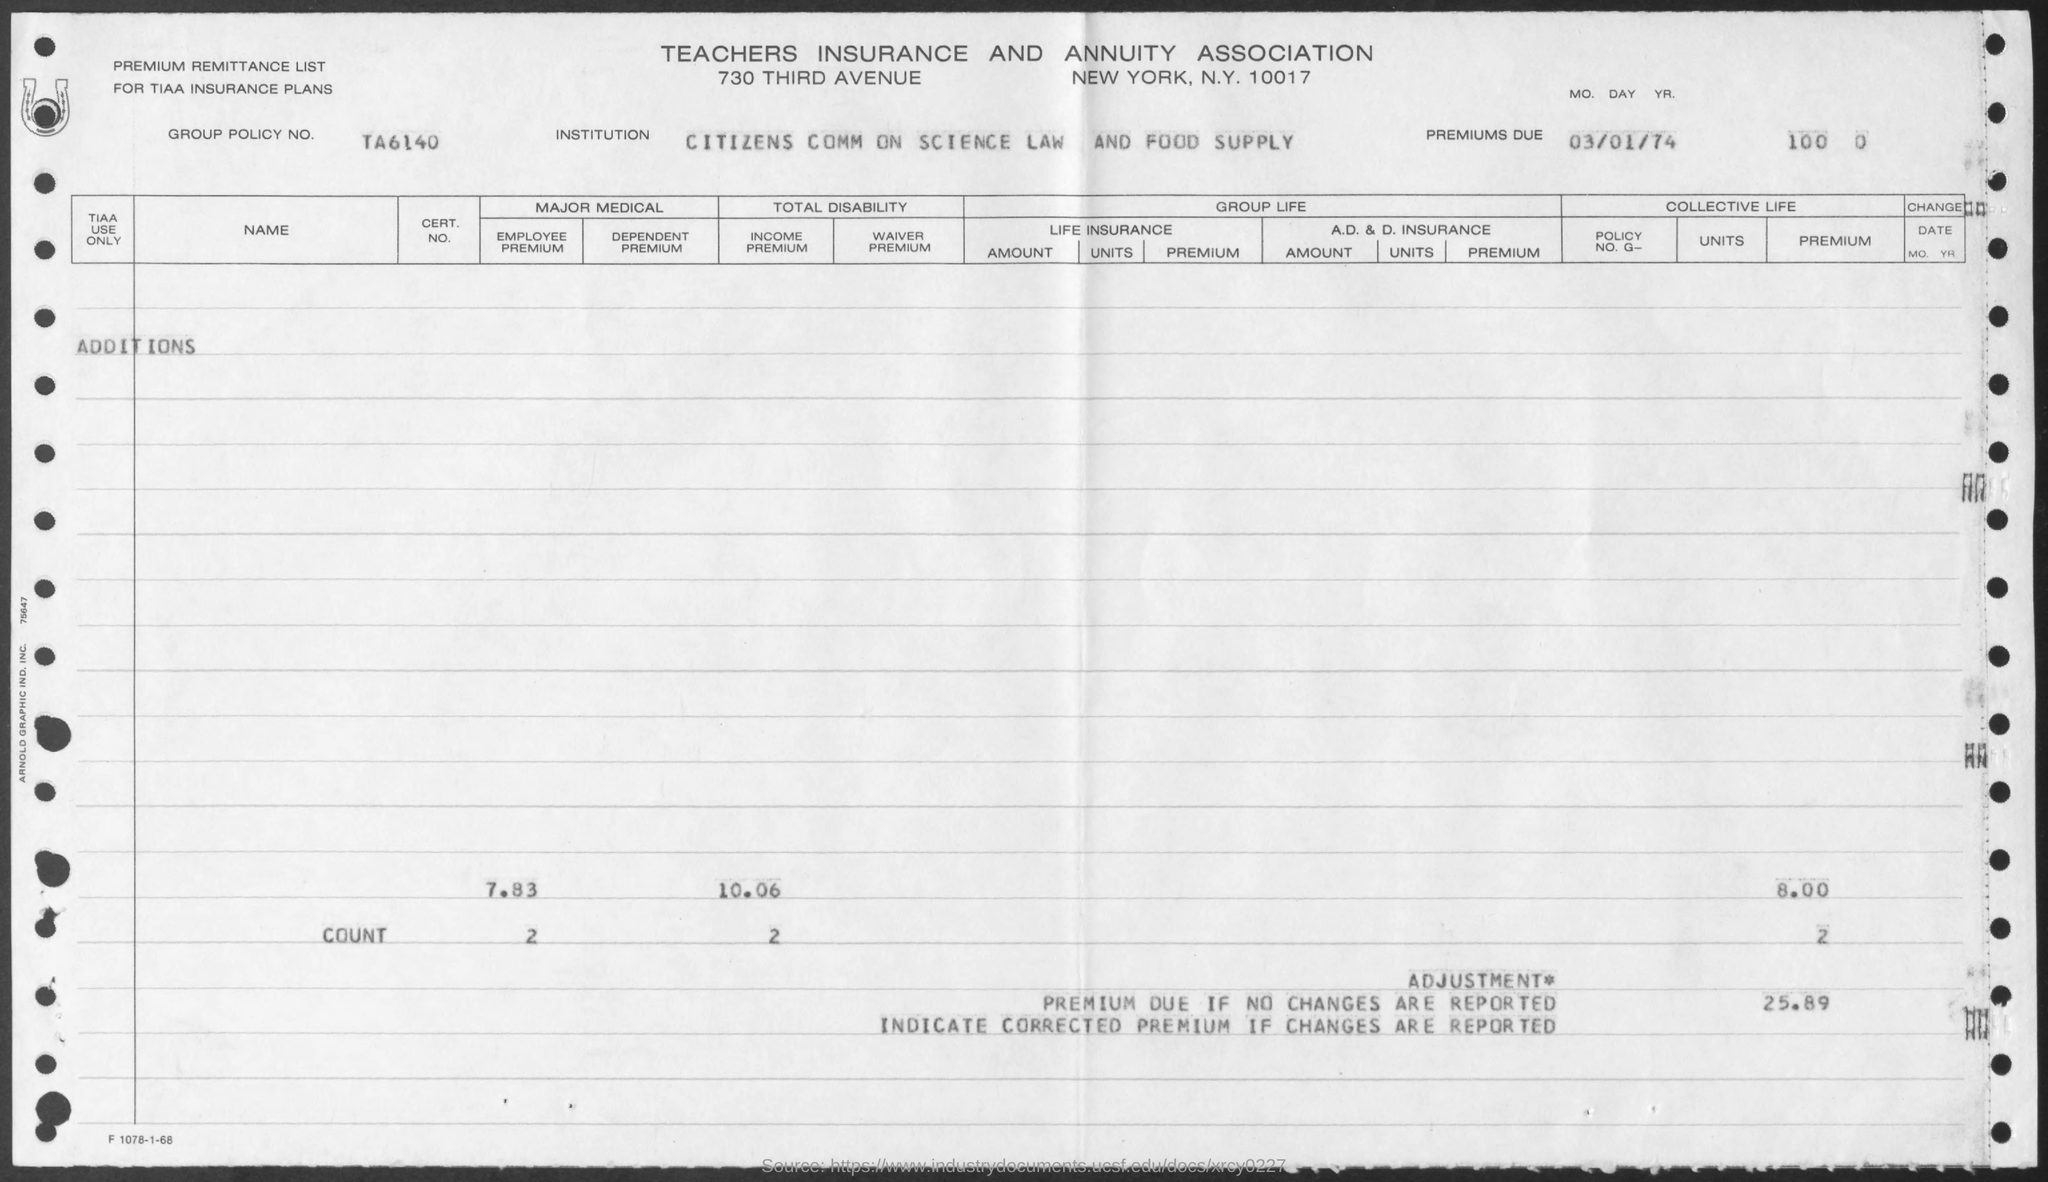List a handful of essential elements in this visual. The date mentioned is March 1, 1974. The group policy is No. TA6140... 